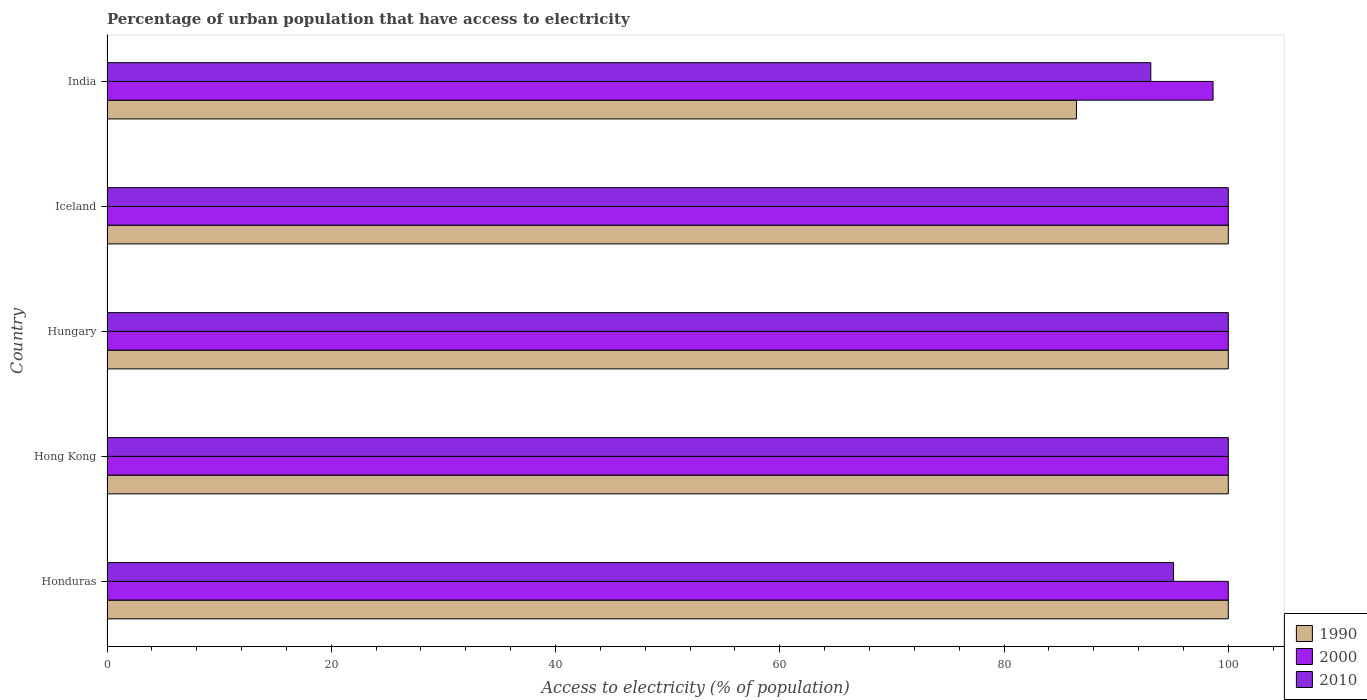Are the number of bars per tick equal to the number of legend labels?
Your response must be concise. Yes. Are the number of bars on each tick of the Y-axis equal?
Provide a succinct answer. Yes. How many bars are there on the 4th tick from the top?
Make the answer very short. 3. How many bars are there on the 3rd tick from the bottom?
Ensure brevity in your answer.  3. What is the label of the 2nd group of bars from the top?
Provide a succinct answer. Iceland. Across all countries, what is the minimum percentage of urban population that have access to electricity in 1990?
Make the answer very short. 86.46. In which country was the percentage of urban population that have access to electricity in 1990 maximum?
Provide a short and direct response. Honduras. What is the total percentage of urban population that have access to electricity in 2010 in the graph?
Provide a short and direct response. 488.2. What is the difference between the percentage of urban population that have access to electricity in 2000 in Hungary and that in India?
Provide a succinct answer. 1.36. What is the difference between the percentage of urban population that have access to electricity in 2010 in Hong Kong and the percentage of urban population that have access to electricity in 1990 in Honduras?
Provide a succinct answer. 0. What is the average percentage of urban population that have access to electricity in 1990 per country?
Your answer should be very brief. 97.29. What is the difference between the percentage of urban population that have access to electricity in 2000 and percentage of urban population that have access to electricity in 2010 in Honduras?
Offer a very short reply. 4.88. In how many countries, is the percentage of urban population that have access to electricity in 2010 greater than 32 %?
Make the answer very short. 5. What is the ratio of the percentage of urban population that have access to electricity in 1990 in Hong Kong to that in Iceland?
Provide a short and direct response. 1. Is the percentage of urban population that have access to electricity in 1990 in Hong Kong less than that in India?
Offer a very short reply. No. What is the difference between the highest and the lowest percentage of urban population that have access to electricity in 1990?
Give a very brief answer. 13.54. In how many countries, is the percentage of urban population that have access to electricity in 2000 greater than the average percentage of urban population that have access to electricity in 2000 taken over all countries?
Provide a short and direct response. 4. Is the sum of the percentage of urban population that have access to electricity in 1990 in Honduras and Hungary greater than the maximum percentage of urban population that have access to electricity in 2010 across all countries?
Provide a short and direct response. Yes. What does the 3rd bar from the top in Hong Kong represents?
Offer a terse response. 1990. What does the 1st bar from the bottom in Hungary represents?
Offer a very short reply. 1990. How many bars are there?
Provide a short and direct response. 15. Are all the bars in the graph horizontal?
Make the answer very short. Yes. What is the difference between two consecutive major ticks on the X-axis?
Ensure brevity in your answer.  20. Are the values on the major ticks of X-axis written in scientific E-notation?
Ensure brevity in your answer.  No. Does the graph contain any zero values?
Your response must be concise. No. Does the graph contain grids?
Keep it short and to the point. No. What is the title of the graph?
Offer a very short reply. Percentage of urban population that have access to electricity. Does "1999" appear as one of the legend labels in the graph?
Provide a short and direct response. No. What is the label or title of the X-axis?
Offer a very short reply. Access to electricity (% of population). What is the Access to electricity (% of population) in 1990 in Honduras?
Your answer should be very brief. 100. What is the Access to electricity (% of population) of 2000 in Honduras?
Offer a very short reply. 100. What is the Access to electricity (% of population) of 2010 in Honduras?
Your response must be concise. 95.12. What is the Access to electricity (% of population) of 2000 in Hong Kong?
Make the answer very short. 100. What is the Access to electricity (% of population) of 2010 in Iceland?
Provide a short and direct response. 100. What is the Access to electricity (% of population) of 1990 in India?
Provide a short and direct response. 86.46. What is the Access to electricity (% of population) in 2000 in India?
Offer a very short reply. 98.64. What is the Access to electricity (% of population) of 2010 in India?
Your answer should be very brief. 93.09. Across all countries, what is the maximum Access to electricity (% of population) of 2000?
Provide a succinct answer. 100. Across all countries, what is the minimum Access to electricity (% of population) in 1990?
Your answer should be very brief. 86.46. Across all countries, what is the minimum Access to electricity (% of population) in 2000?
Offer a terse response. 98.64. Across all countries, what is the minimum Access to electricity (% of population) of 2010?
Offer a very short reply. 93.09. What is the total Access to electricity (% of population) of 1990 in the graph?
Offer a terse response. 486.46. What is the total Access to electricity (% of population) of 2000 in the graph?
Keep it short and to the point. 498.64. What is the total Access to electricity (% of population) in 2010 in the graph?
Ensure brevity in your answer.  488.2. What is the difference between the Access to electricity (% of population) of 2000 in Honduras and that in Hong Kong?
Keep it short and to the point. 0. What is the difference between the Access to electricity (% of population) of 2010 in Honduras and that in Hong Kong?
Make the answer very short. -4.88. What is the difference between the Access to electricity (% of population) in 2010 in Honduras and that in Hungary?
Offer a terse response. -4.88. What is the difference between the Access to electricity (% of population) in 1990 in Honduras and that in Iceland?
Keep it short and to the point. 0. What is the difference between the Access to electricity (% of population) of 2000 in Honduras and that in Iceland?
Make the answer very short. 0. What is the difference between the Access to electricity (% of population) in 2010 in Honduras and that in Iceland?
Give a very brief answer. -4.88. What is the difference between the Access to electricity (% of population) of 1990 in Honduras and that in India?
Your answer should be very brief. 13.54. What is the difference between the Access to electricity (% of population) in 2000 in Honduras and that in India?
Your answer should be very brief. 1.36. What is the difference between the Access to electricity (% of population) in 2010 in Honduras and that in India?
Your answer should be very brief. 2.03. What is the difference between the Access to electricity (% of population) of 1990 in Hong Kong and that in Iceland?
Your answer should be very brief. 0. What is the difference between the Access to electricity (% of population) of 2010 in Hong Kong and that in Iceland?
Provide a short and direct response. 0. What is the difference between the Access to electricity (% of population) of 1990 in Hong Kong and that in India?
Keep it short and to the point. 13.54. What is the difference between the Access to electricity (% of population) of 2000 in Hong Kong and that in India?
Provide a short and direct response. 1.36. What is the difference between the Access to electricity (% of population) in 2010 in Hong Kong and that in India?
Keep it short and to the point. 6.91. What is the difference between the Access to electricity (% of population) in 2000 in Hungary and that in Iceland?
Provide a succinct answer. 0. What is the difference between the Access to electricity (% of population) in 1990 in Hungary and that in India?
Your answer should be very brief. 13.54. What is the difference between the Access to electricity (% of population) in 2000 in Hungary and that in India?
Make the answer very short. 1.36. What is the difference between the Access to electricity (% of population) of 2010 in Hungary and that in India?
Your answer should be compact. 6.91. What is the difference between the Access to electricity (% of population) in 1990 in Iceland and that in India?
Provide a succinct answer. 13.54. What is the difference between the Access to electricity (% of population) in 2000 in Iceland and that in India?
Offer a terse response. 1.36. What is the difference between the Access to electricity (% of population) of 2010 in Iceland and that in India?
Provide a succinct answer. 6.91. What is the difference between the Access to electricity (% of population) of 1990 in Honduras and the Access to electricity (% of population) of 2000 in Hong Kong?
Make the answer very short. 0. What is the difference between the Access to electricity (% of population) of 1990 in Honduras and the Access to electricity (% of population) of 2000 in Hungary?
Your response must be concise. 0. What is the difference between the Access to electricity (% of population) in 2000 in Honduras and the Access to electricity (% of population) in 2010 in Iceland?
Make the answer very short. 0. What is the difference between the Access to electricity (% of population) in 1990 in Honduras and the Access to electricity (% of population) in 2000 in India?
Your response must be concise. 1.36. What is the difference between the Access to electricity (% of population) in 1990 in Honduras and the Access to electricity (% of population) in 2010 in India?
Ensure brevity in your answer.  6.91. What is the difference between the Access to electricity (% of population) of 2000 in Honduras and the Access to electricity (% of population) of 2010 in India?
Your answer should be very brief. 6.91. What is the difference between the Access to electricity (% of population) in 2000 in Hong Kong and the Access to electricity (% of population) in 2010 in Hungary?
Offer a terse response. 0. What is the difference between the Access to electricity (% of population) in 1990 in Hong Kong and the Access to electricity (% of population) in 2000 in Iceland?
Provide a succinct answer. 0. What is the difference between the Access to electricity (% of population) of 1990 in Hong Kong and the Access to electricity (% of population) of 2010 in Iceland?
Your response must be concise. 0. What is the difference between the Access to electricity (% of population) of 2000 in Hong Kong and the Access to electricity (% of population) of 2010 in Iceland?
Your answer should be very brief. 0. What is the difference between the Access to electricity (% of population) of 1990 in Hong Kong and the Access to electricity (% of population) of 2000 in India?
Your answer should be compact. 1.36. What is the difference between the Access to electricity (% of population) in 1990 in Hong Kong and the Access to electricity (% of population) in 2010 in India?
Your answer should be compact. 6.91. What is the difference between the Access to electricity (% of population) in 2000 in Hong Kong and the Access to electricity (% of population) in 2010 in India?
Your answer should be compact. 6.91. What is the difference between the Access to electricity (% of population) of 2000 in Hungary and the Access to electricity (% of population) of 2010 in Iceland?
Ensure brevity in your answer.  0. What is the difference between the Access to electricity (% of population) in 1990 in Hungary and the Access to electricity (% of population) in 2000 in India?
Provide a succinct answer. 1.36. What is the difference between the Access to electricity (% of population) of 1990 in Hungary and the Access to electricity (% of population) of 2010 in India?
Your answer should be compact. 6.91. What is the difference between the Access to electricity (% of population) in 2000 in Hungary and the Access to electricity (% of population) in 2010 in India?
Provide a short and direct response. 6.91. What is the difference between the Access to electricity (% of population) in 1990 in Iceland and the Access to electricity (% of population) in 2000 in India?
Your answer should be compact. 1.36. What is the difference between the Access to electricity (% of population) in 1990 in Iceland and the Access to electricity (% of population) in 2010 in India?
Make the answer very short. 6.91. What is the difference between the Access to electricity (% of population) of 2000 in Iceland and the Access to electricity (% of population) of 2010 in India?
Keep it short and to the point. 6.91. What is the average Access to electricity (% of population) of 1990 per country?
Your response must be concise. 97.29. What is the average Access to electricity (% of population) of 2000 per country?
Your answer should be very brief. 99.73. What is the average Access to electricity (% of population) of 2010 per country?
Your answer should be compact. 97.64. What is the difference between the Access to electricity (% of population) of 1990 and Access to electricity (% of population) of 2010 in Honduras?
Offer a terse response. 4.88. What is the difference between the Access to electricity (% of population) of 2000 and Access to electricity (% of population) of 2010 in Honduras?
Make the answer very short. 4.88. What is the difference between the Access to electricity (% of population) in 1990 and Access to electricity (% of population) in 2010 in Hong Kong?
Your answer should be compact. 0. What is the difference between the Access to electricity (% of population) in 2000 and Access to electricity (% of population) in 2010 in Hong Kong?
Your answer should be compact. 0. What is the difference between the Access to electricity (% of population) in 1990 and Access to electricity (% of population) in 2000 in Hungary?
Ensure brevity in your answer.  0. What is the difference between the Access to electricity (% of population) in 1990 and Access to electricity (% of population) in 2010 in Hungary?
Give a very brief answer. 0. What is the difference between the Access to electricity (% of population) of 2000 and Access to electricity (% of population) of 2010 in Hungary?
Your answer should be very brief. 0. What is the difference between the Access to electricity (% of population) of 1990 and Access to electricity (% of population) of 2000 in Iceland?
Offer a very short reply. 0. What is the difference between the Access to electricity (% of population) of 1990 and Access to electricity (% of population) of 2010 in Iceland?
Provide a succinct answer. 0. What is the difference between the Access to electricity (% of population) in 1990 and Access to electricity (% of population) in 2000 in India?
Your response must be concise. -12.19. What is the difference between the Access to electricity (% of population) of 1990 and Access to electricity (% of population) of 2010 in India?
Keep it short and to the point. -6.63. What is the difference between the Access to electricity (% of population) in 2000 and Access to electricity (% of population) in 2010 in India?
Provide a succinct answer. 5.55. What is the ratio of the Access to electricity (% of population) in 2010 in Honduras to that in Hong Kong?
Provide a succinct answer. 0.95. What is the ratio of the Access to electricity (% of population) of 2010 in Honduras to that in Hungary?
Ensure brevity in your answer.  0.95. What is the ratio of the Access to electricity (% of population) in 1990 in Honduras to that in Iceland?
Provide a succinct answer. 1. What is the ratio of the Access to electricity (% of population) in 2000 in Honduras to that in Iceland?
Your answer should be very brief. 1. What is the ratio of the Access to electricity (% of population) in 2010 in Honduras to that in Iceland?
Ensure brevity in your answer.  0.95. What is the ratio of the Access to electricity (% of population) in 1990 in Honduras to that in India?
Provide a succinct answer. 1.16. What is the ratio of the Access to electricity (% of population) of 2000 in Honduras to that in India?
Keep it short and to the point. 1.01. What is the ratio of the Access to electricity (% of population) in 2010 in Honduras to that in India?
Give a very brief answer. 1.02. What is the ratio of the Access to electricity (% of population) in 2000 in Hong Kong to that in Hungary?
Your response must be concise. 1. What is the ratio of the Access to electricity (% of population) of 2000 in Hong Kong to that in Iceland?
Offer a very short reply. 1. What is the ratio of the Access to electricity (% of population) of 2010 in Hong Kong to that in Iceland?
Make the answer very short. 1. What is the ratio of the Access to electricity (% of population) of 1990 in Hong Kong to that in India?
Your answer should be very brief. 1.16. What is the ratio of the Access to electricity (% of population) of 2000 in Hong Kong to that in India?
Provide a short and direct response. 1.01. What is the ratio of the Access to electricity (% of population) of 2010 in Hong Kong to that in India?
Your response must be concise. 1.07. What is the ratio of the Access to electricity (% of population) of 2010 in Hungary to that in Iceland?
Provide a succinct answer. 1. What is the ratio of the Access to electricity (% of population) of 1990 in Hungary to that in India?
Provide a short and direct response. 1.16. What is the ratio of the Access to electricity (% of population) in 2000 in Hungary to that in India?
Offer a terse response. 1.01. What is the ratio of the Access to electricity (% of population) of 2010 in Hungary to that in India?
Keep it short and to the point. 1.07. What is the ratio of the Access to electricity (% of population) in 1990 in Iceland to that in India?
Your response must be concise. 1.16. What is the ratio of the Access to electricity (% of population) in 2000 in Iceland to that in India?
Offer a very short reply. 1.01. What is the ratio of the Access to electricity (% of population) in 2010 in Iceland to that in India?
Your response must be concise. 1.07. What is the difference between the highest and the second highest Access to electricity (% of population) of 2000?
Provide a succinct answer. 0. What is the difference between the highest and the second highest Access to electricity (% of population) of 2010?
Keep it short and to the point. 0. What is the difference between the highest and the lowest Access to electricity (% of population) in 1990?
Make the answer very short. 13.54. What is the difference between the highest and the lowest Access to electricity (% of population) in 2000?
Your response must be concise. 1.36. What is the difference between the highest and the lowest Access to electricity (% of population) in 2010?
Ensure brevity in your answer.  6.91. 